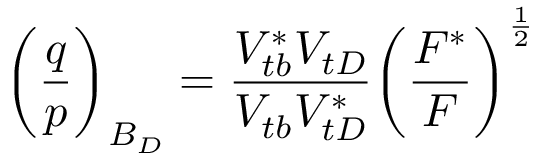Convert formula to latex. <formula><loc_0><loc_0><loc_500><loc_500>\left ( { \frac { q } { p } } \right ) _ { B _ { D } } = { \frac { V _ { t b } ^ { * } V _ { t D } } { V _ { t b } V _ { t D } ^ { * } } } \left ( { \frac { F ^ { * } } { F } } \right ) ^ { \frac { 1 } { 2 } }</formula> 